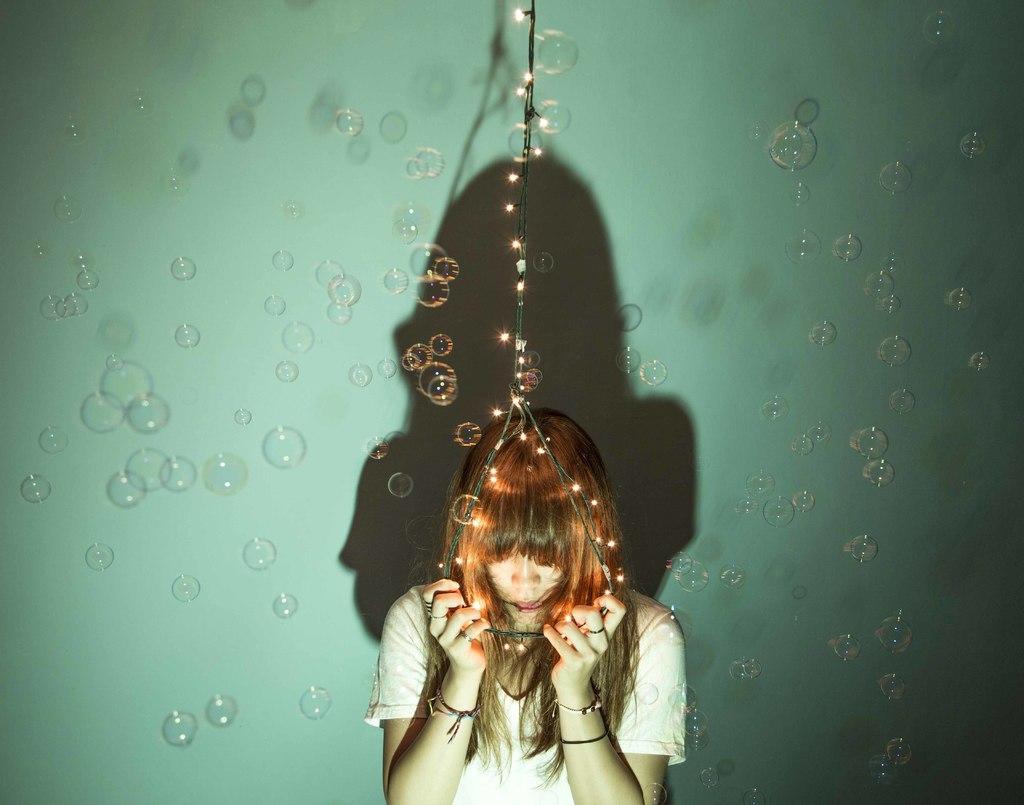In one or two sentences, can you explain what this image depicts? This picture shows few air bubbles and we see a woman standing and holding wire with her hands and we see lights to the wire. 